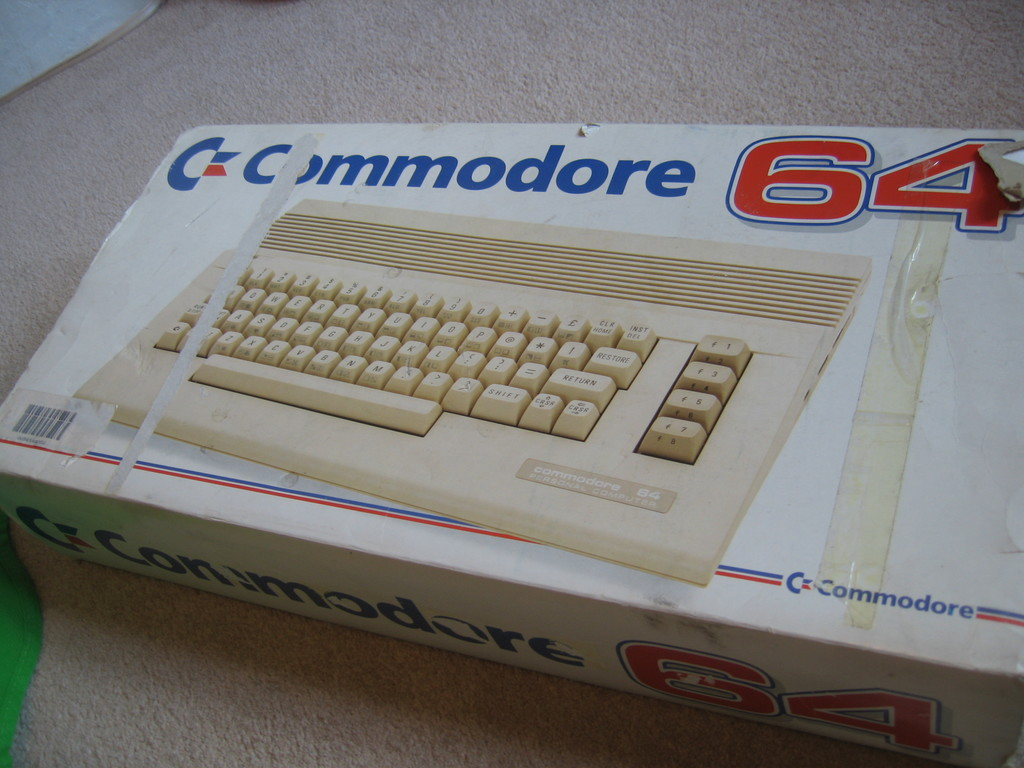Provide a one-sentence caption for the provided image. The image shows an aged, slightly worn packaging box of the iconic Commodore 64 home computer with visible scotch tape and creases, hinting at the product's storied past and cherished value among vintage technology enthusiasts. 